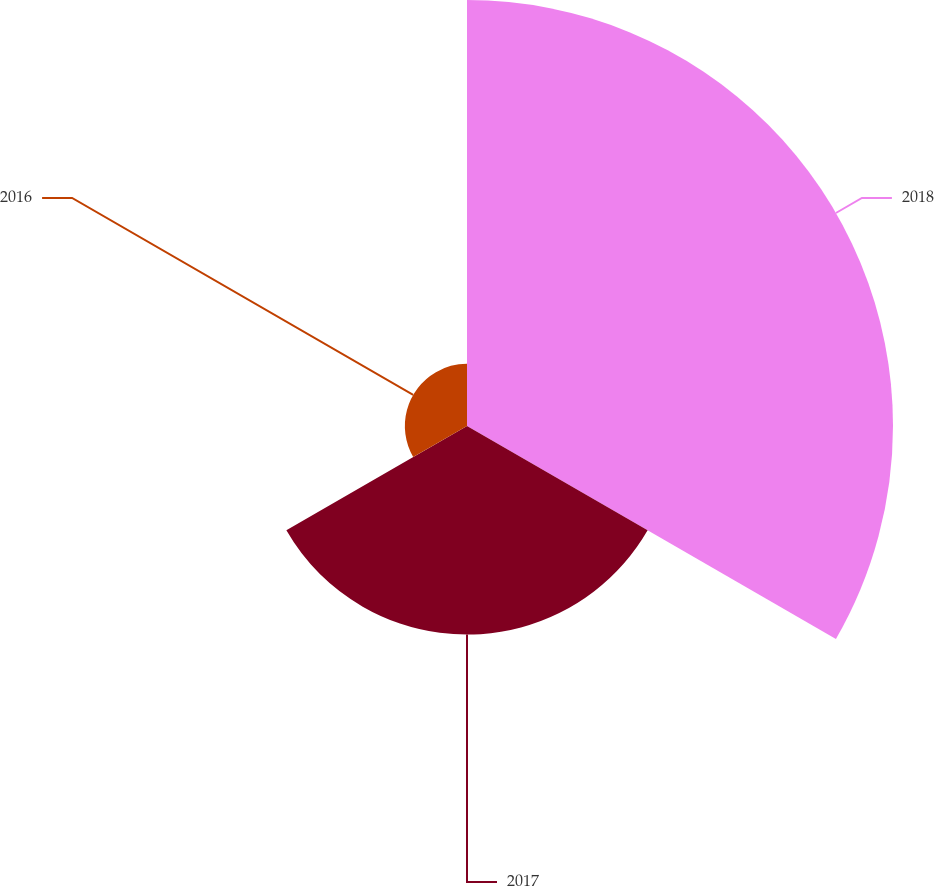<chart> <loc_0><loc_0><loc_500><loc_500><pie_chart><fcel>2018<fcel>2017<fcel>2016<nl><fcel>61.15%<fcel>29.94%<fcel>8.92%<nl></chart> 